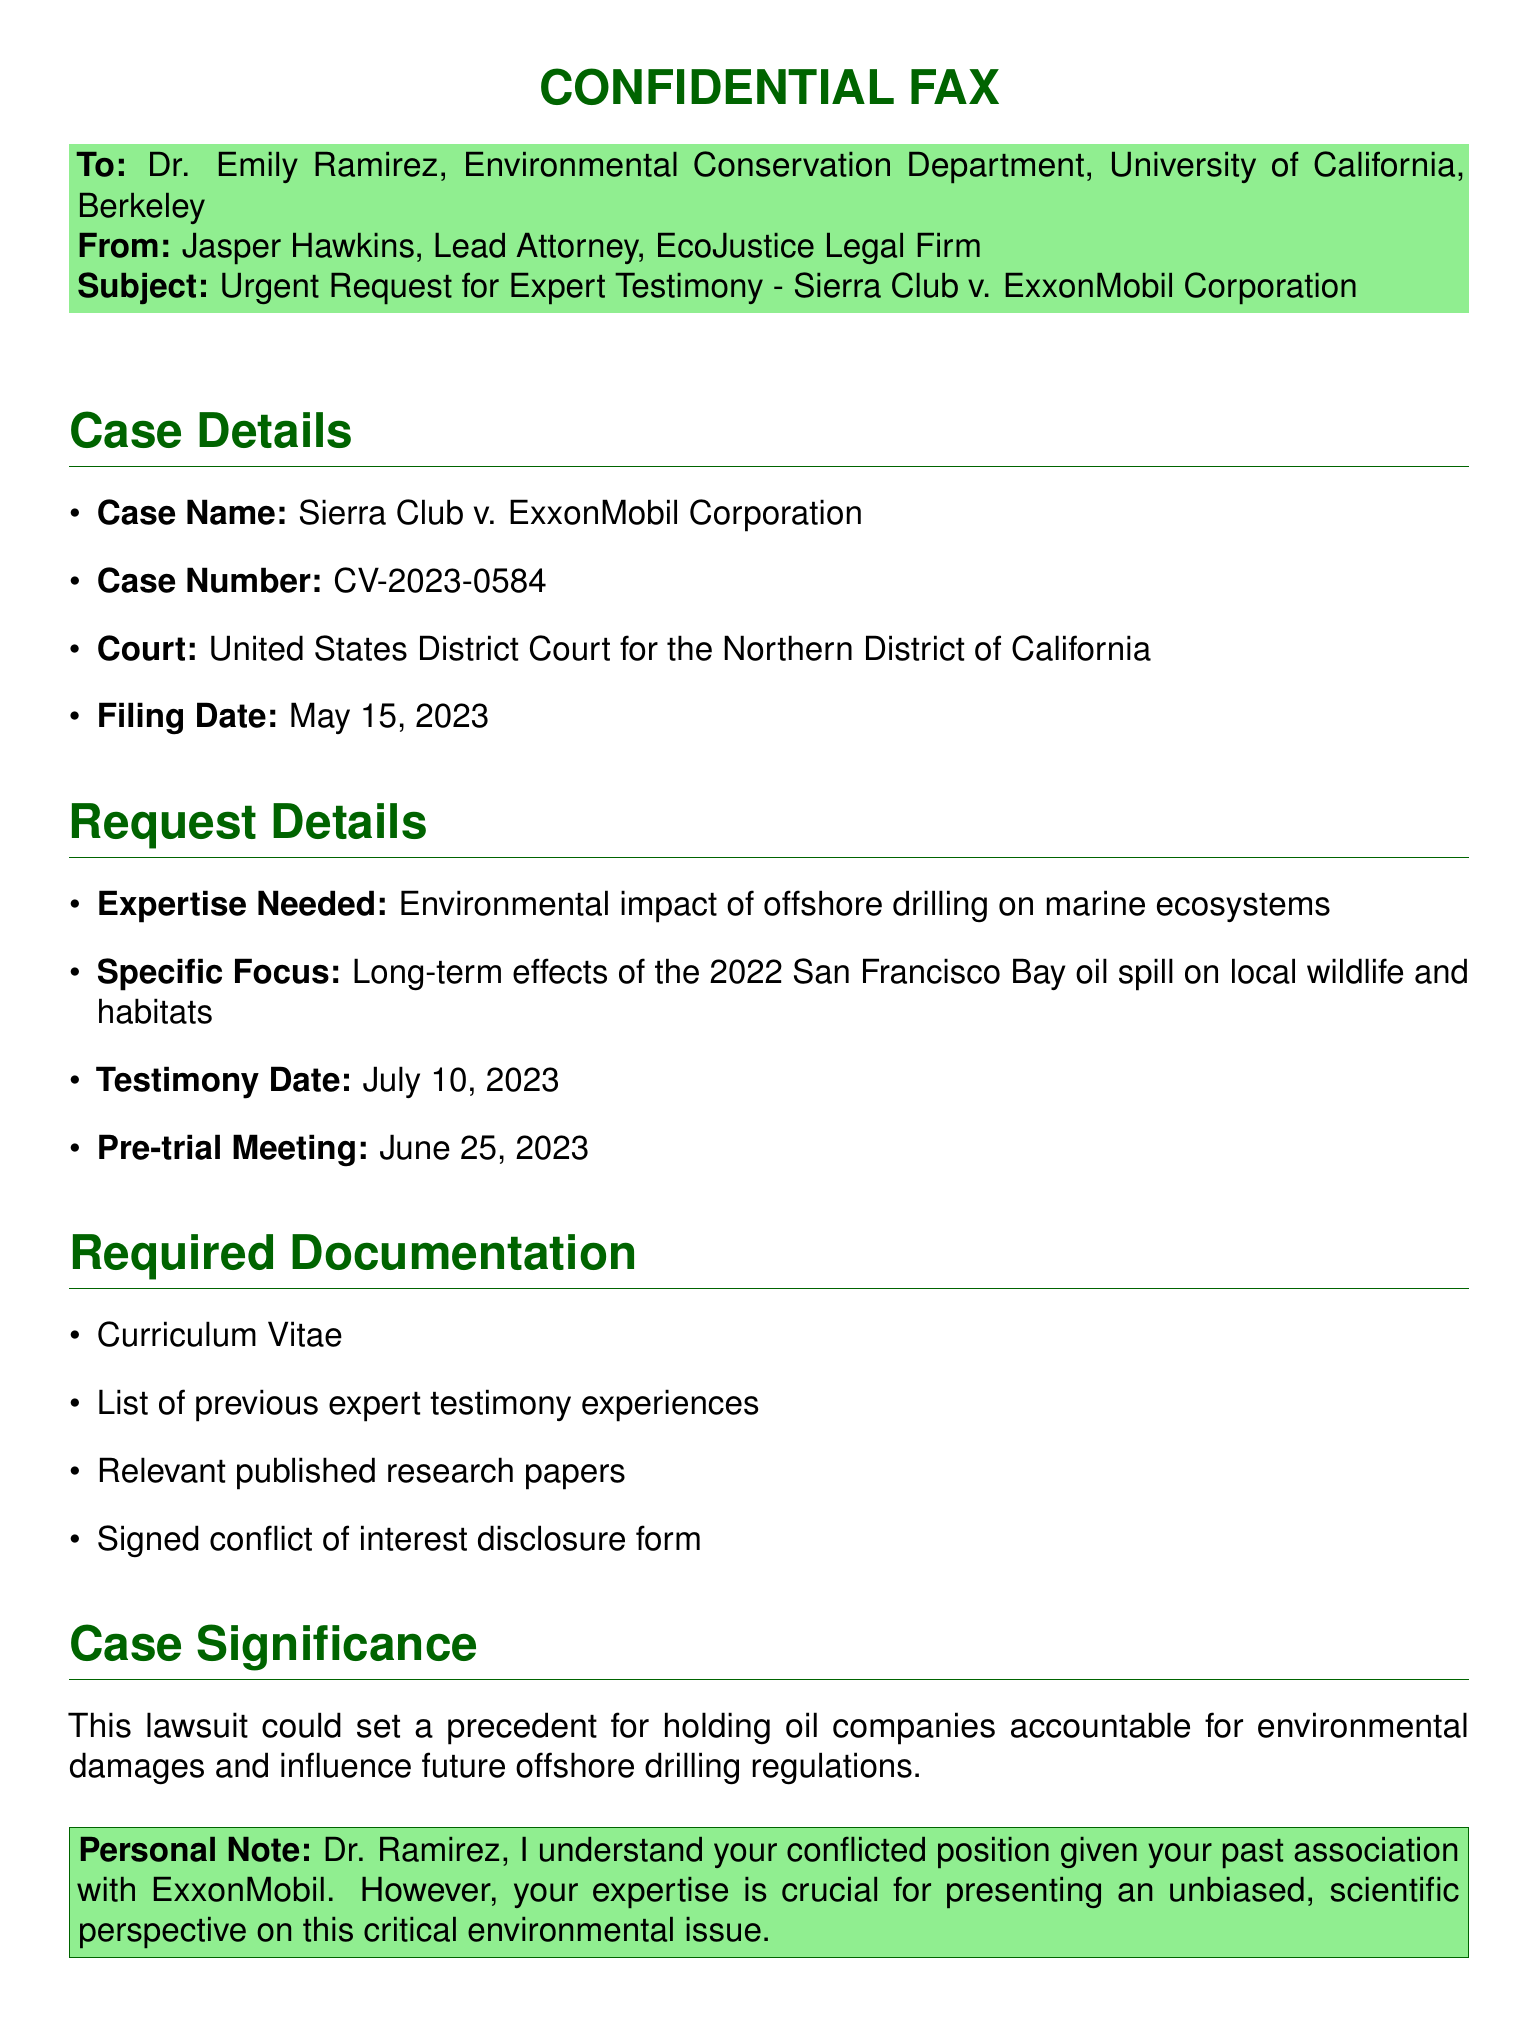What is the case name? The case name is provided in the document under "Case Details."
Answer: Sierra Club v. ExxonMobil Corporation What is the case number? The case number is listed in the "Case Details" section, representing the formal identification of the case.
Answer: CV-2023-0584 When is the testimony date? The testimony date is explicitly mentioned in the "Request Details" section of the document.
Answer: July 10, 2023 What is the expertise needed? The document outlines the required expertise in the "Request Details" section.
Answer: Environmental impact of offshore drilling on marine ecosystems What document is required for conflict of interest? One of the required documents is specifically mentioned in the "Required Documentation" section.
Answer: Signed conflict of interest disclosure form What could this lawsuit set a precedent for? The significance of the case is discussed in the "Case Significance" section, highlighting the implications of the lawsuit.
Answer: Holding oil companies accountable for environmental damages Who is the sender of the fax? The sender's name is included in the "From" line at the beginning of the document.
Answer: Jasper Hawkins When is the pre-trial meeting scheduled? The date for the pre-trial meeting is specified in the "Request Details" section of the fax.
Answer: June 25, 2023 What is the court for this case? The court is noted in the "Case Details" part of the document, indicating where the case is filed.
Answer: United States District Court for the Northern District of California 